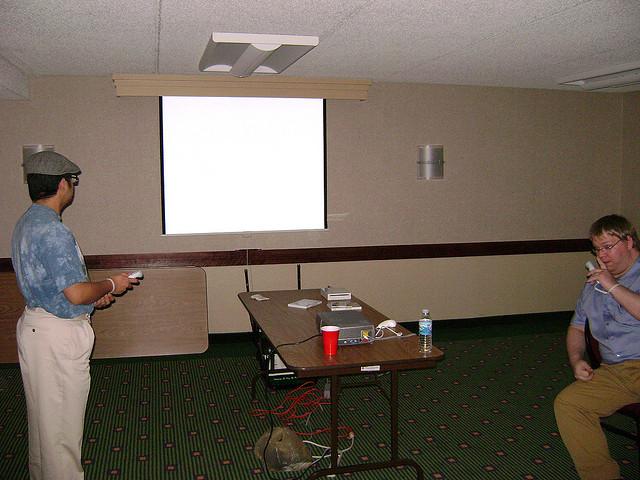What kind of bottle is on the table?
Quick response, please. Water. What is the red object?
Write a very short answer. Cup. Is there anything on the screen?
Answer briefly. No. Are the lights on?
Quick response, please. No. What kind of hat is he wearing?
Keep it brief. Fedora. 